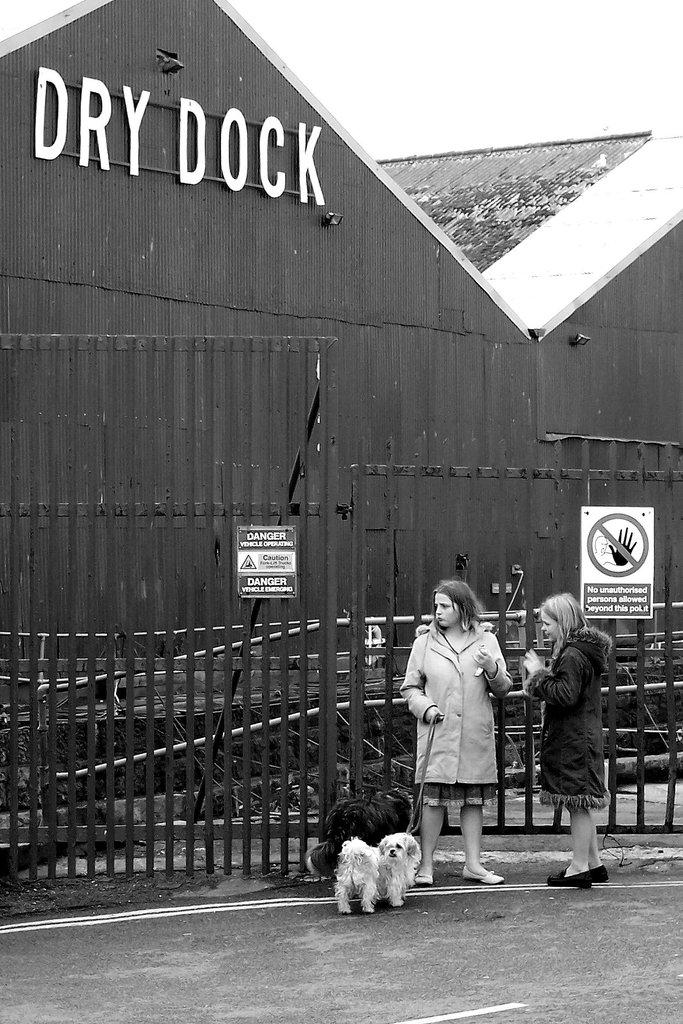What is the main subject in the image? There is a girl in the image. What is the girl doing in the image? The girl is standing in the image. What is the girl holding in the image? The girl is holding two puppies in the image. Who else is present in the image? There is a woman in the image. What is the woman doing in the image? The woman is talking in the image. What type of letters can be seen floating around the girl in the image? There are no letters floating around the girl in the image. What is the girl pointing at in the image? There is no indication in the image that the girl is pointing at anything. 